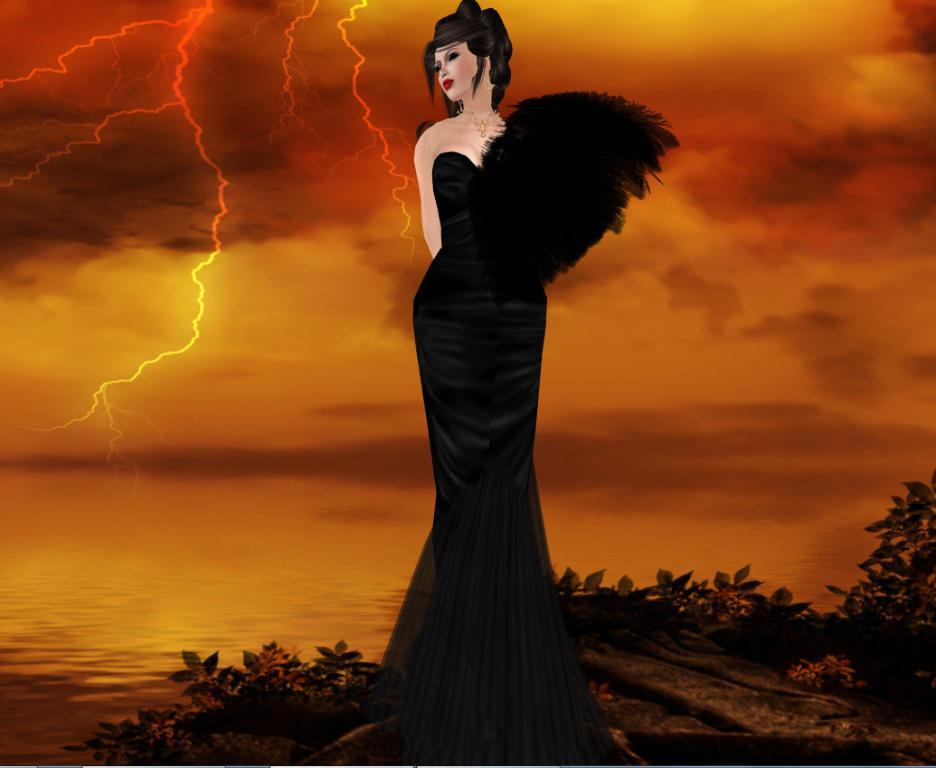What type of image is being described? The image is an animation. What is the woman in the image doing? The woman is standing on the ground. What can be seen in the background of the image? The background of the image includes the sky, water, and plants. What color is the rose that the woman is holding in the image? There is no rose present in the image; the woman is standing on the ground with no visible objects in her hands. 